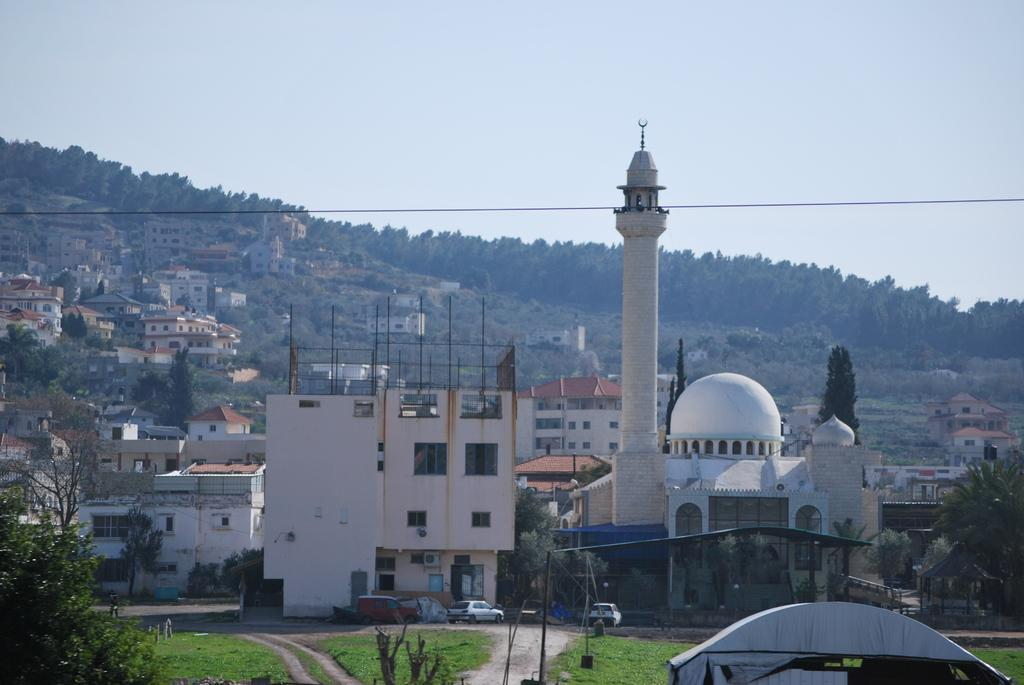What type of structures are located in the middle of the image? There are buildings in the middle of the image. What can be seen at the bottom of the image? There are parked cars at the bottom of the image. What type of vegetation is on the left side of the image? There are green trees on the left side of the image. What is visible at the top of the image? The sky is visible at the top of the image. Are there any giants visible in the image? No, there are no giants present in the image. What type of picture is being taken in the image? There is no indication of a picture being taken in the image; it simply shows buildings, parked cars, green trees, and the sky. 